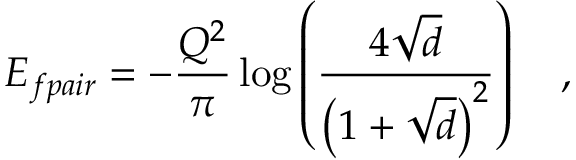<formula> <loc_0><loc_0><loc_500><loc_500>E _ { f p a i r } = - \frac { Q ^ { 2 } } { \pi } \log \left ( \frac { 4 \sqrt { d } } { \left ( 1 + \sqrt { d } \right ) ^ { 2 } } \right ) \quad ,</formula> 